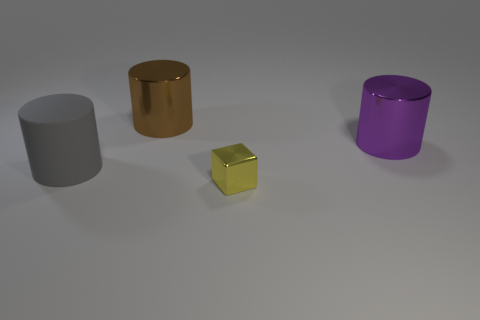Subtract all shiny cylinders. How many cylinders are left? 1 Add 1 large yellow cubes. How many objects exist? 5 Subtract all blue cylinders. Subtract all purple spheres. How many cylinders are left? 3 Subtract all big rubber cylinders. Subtract all small purple rubber cylinders. How many objects are left? 3 Add 4 shiny objects. How many shiny objects are left? 7 Add 1 small brown things. How many small brown things exist? 1 Subtract 0 green spheres. How many objects are left? 4 Subtract all cylinders. How many objects are left? 1 